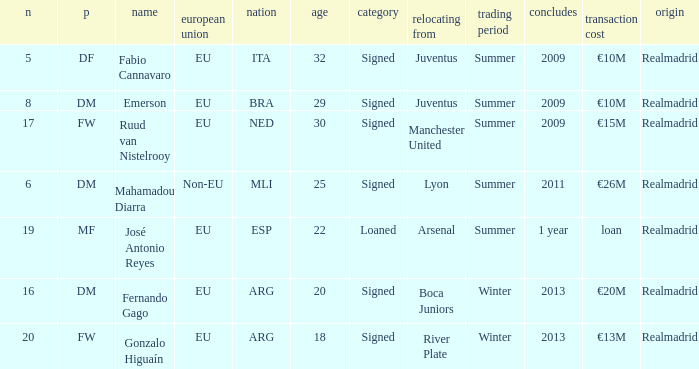What is the type of the player whose transfer fee was €20m? Signed. 